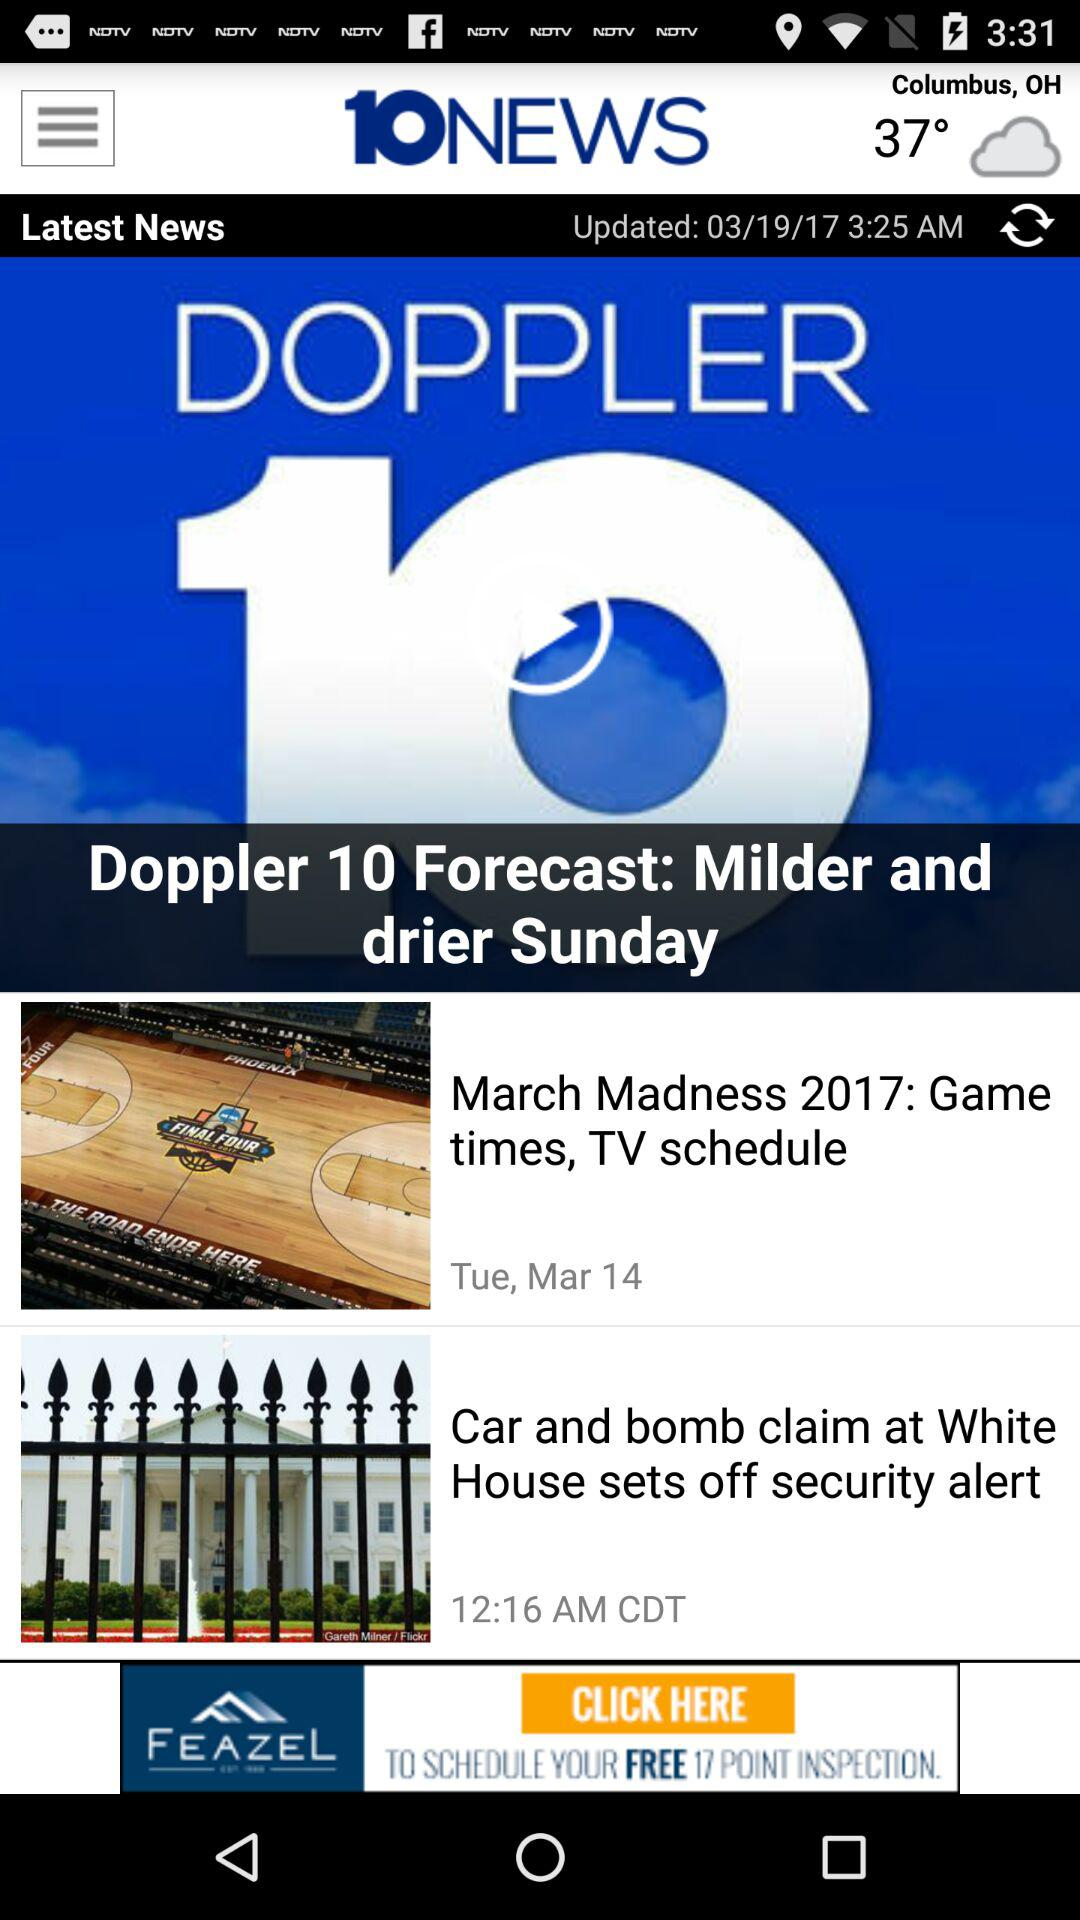What is the weather forecast? The weather is cloudy. 